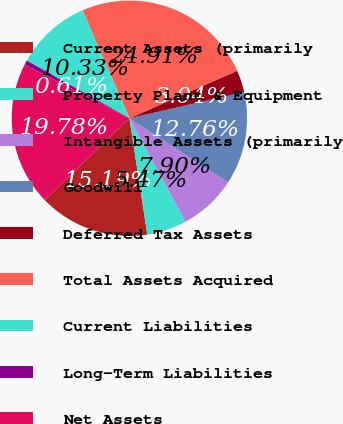Convert chart. <chart><loc_0><loc_0><loc_500><loc_500><pie_chart><fcel>Current Assets (primarily<fcel>Property Plant & Equipment<fcel>Intangible Assets (primarily<fcel>Goodwill<fcel>Deferred Tax Assets<fcel>Total Assets Acquired<fcel>Current Liabilities<fcel>Long-Term Liabilities<fcel>Net Assets<nl><fcel>15.19%<fcel>5.47%<fcel>7.9%<fcel>12.76%<fcel>3.04%<fcel>24.91%<fcel>10.33%<fcel>0.61%<fcel>19.78%<nl></chart> 